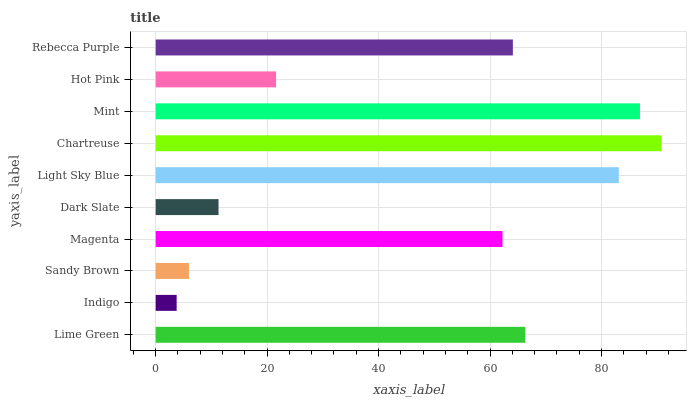Is Indigo the minimum?
Answer yes or no. Yes. Is Chartreuse the maximum?
Answer yes or no. Yes. Is Sandy Brown the minimum?
Answer yes or no. No. Is Sandy Brown the maximum?
Answer yes or no. No. Is Sandy Brown greater than Indigo?
Answer yes or no. Yes. Is Indigo less than Sandy Brown?
Answer yes or no. Yes. Is Indigo greater than Sandy Brown?
Answer yes or no. No. Is Sandy Brown less than Indigo?
Answer yes or no. No. Is Rebecca Purple the high median?
Answer yes or no. Yes. Is Magenta the low median?
Answer yes or no. Yes. Is Sandy Brown the high median?
Answer yes or no. No. Is Dark Slate the low median?
Answer yes or no. No. 